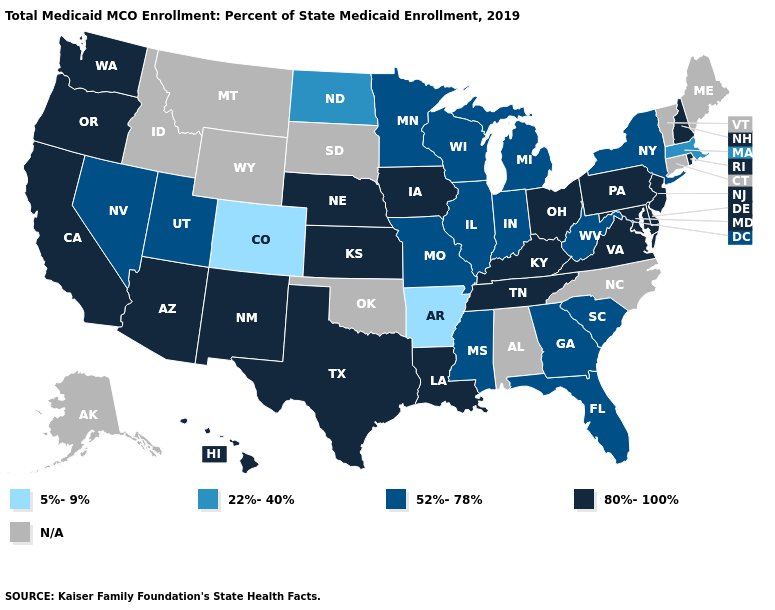Name the states that have a value in the range N/A?
Concise answer only. Alabama, Alaska, Connecticut, Idaho, Maine, Montana, North Carolina, Oklahoma, South Dakota, Vermont, Wyoming. Is the legend a continuous bar?
Quick response, please. No. What is the highest value in the USA?
Keep it brief. 80%-100%. What is the value of New Hampshire?
Give a very brief answer. 80%-100%. Among the states that border Tennessee , which have the highest value?
Quick response, please. Kentucky, Virginia. What is the value of Arizona?
Quick response, please. 80%-100%. Name the states that have a value in the range 5%-9%?
Concise answer only. Arkansas, Colorado. Name the states that have a value in the range 80%-100%?
Short answer required. Arizona, California, Delaware, Hawaii, Iowa, Kansas, Kentucky, Louisiana, Maryland, Nebraska, New Hampshire, New Jersey, New Mexico, Ohio, Oregon, Pennsylvania, Rhode Island, Tennessee, Texas, Virginia, Washington. Name the states that have a value in the range 5%-9%?
Answer briefly. Arkansas, Colorado. Does Arkansas have the lowest value in the USA?
Write a very short answer. Yes. What is the value of Oklahoma?
Write a very short answer. N/A. What is the value of Rhode Island?
Write a very short answer. 80%-100%. Name the states that have a value in the range N/A?
Short answer required. Alabama, Alaska, Connecticut, Idaho, Maine, Montana, North Carolina, Oklahoma, South Dakota, Vermont, Wyoming. What is the value of Wisconsin?
Concise answer only. 52%-78%. 